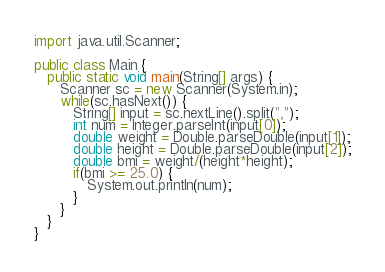<code> <loc_0><loc_0><loc_500><loc_500><_Java_>import java.util.Scanner;

public class Main {
   public static void main(String[] args) {
      Scanner sc = new Scanner(System.in);
      while(sc.hasNext()) {
         String[] input = sc.nextLine().split(",");
         int num = Integer.parseInt(input[0]);
         double weight = Double.parseDouble(input[1]);
         double height = Double.parseDouble(input[2]);
         double bmi = weight/(height*height);
         if(bmi >= 25.0) {
            System.out.println(num);
         }
      }
   }
}
</code> 